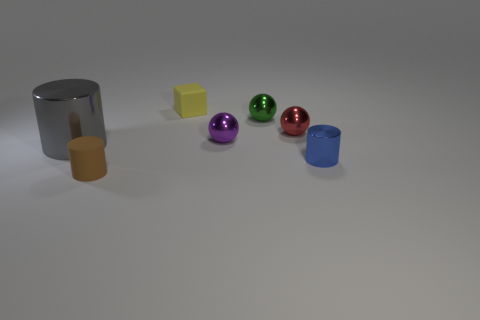Add 1 yellow shiny spheres. How many objects exist? 8 Subtract all balls. How many objects are left? 4 Add 7 red metallic things. How many red metallic things exist? 8 Subtract 0 green cylinders. How many objects are left? 7 Subtract all large purple cubes. Subtract all large gray metal things. How many objects are left? 6 Add 3 small green things. How many small green things are left? 4 